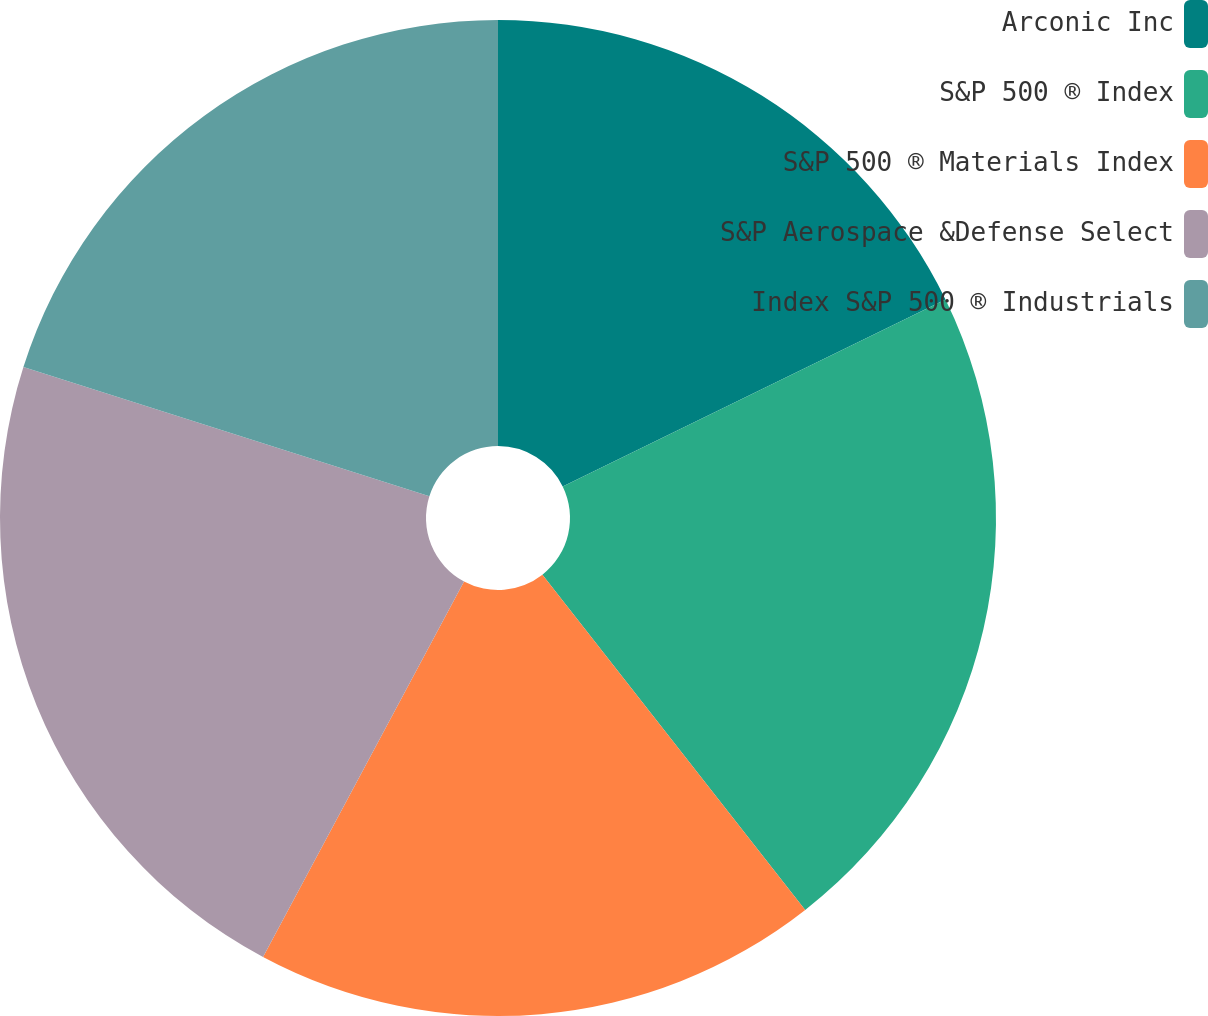<chart> <loc_0><loc_0><loc_500><loc_500><pie_chart><fcel>Arconic Inc<fcel>S&P 500 ® Index<fcel>S&P 500 ® Materials Index<fcel>S&P Aerospace &Defense Select<fcel>Index S&P 500 ® Industrials<nl><fcel>17.77%<fcel>21.65%<fcel>18.4%<fcel>22.08%<fcel>20.1%<nl></chart> 